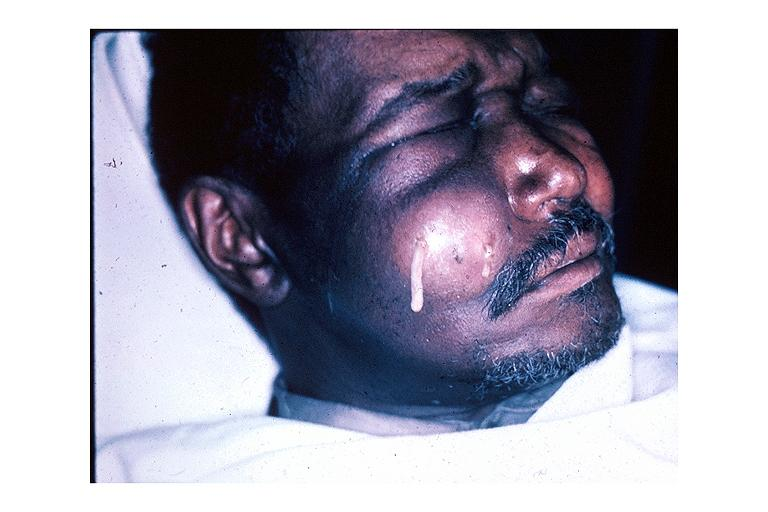what does this image show?
Answer the question using a single word or phrase. Facial abscess 